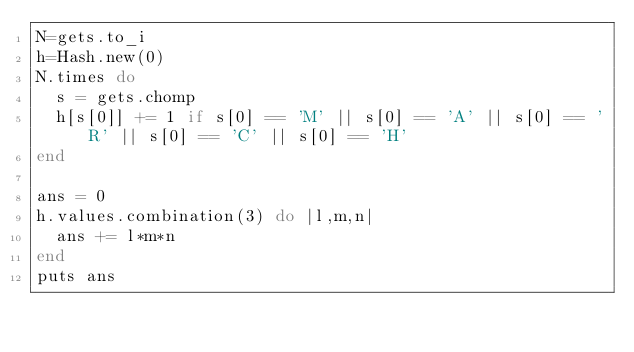Convert code to text. <code><loc_0><loc_0><loc_500><loc_500><_Ruby_>N=gets.to_i
h=Hash.new(0)
N.times do
  s = gets.chomp
  h[s[0]] += 1 if s[0] == 'M' || s[0] == 'A' || s[0] == 'R' || s[0] == 'C' || s[0] == 'H'
end

ans = 0
h.values.combination(3) do |l,m,n|
  ans += l*m*n
end
puts ans
</code> 